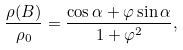<formula> <loc_0><loc_0><loc_500><loc_500>\frac { \rho ( B ) } { \rho _ { 0 } } = \frac { \cos \alpha + \varphi \sin \alpha } { 1 + \varphi ^ { 2 } } ,</formula> 